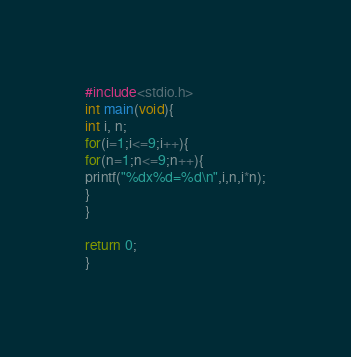<code> <loc_0><loc_0><loc_500><loc_500><_C_>#include<stdio.h>
int main(void){
int i, n;
for(i=1;i<=9;i++){
for(n=1;n<=9;n++){
printf("%dx%d=%d\n",i,n,i*n);
}
}

return 0;
}</code> 